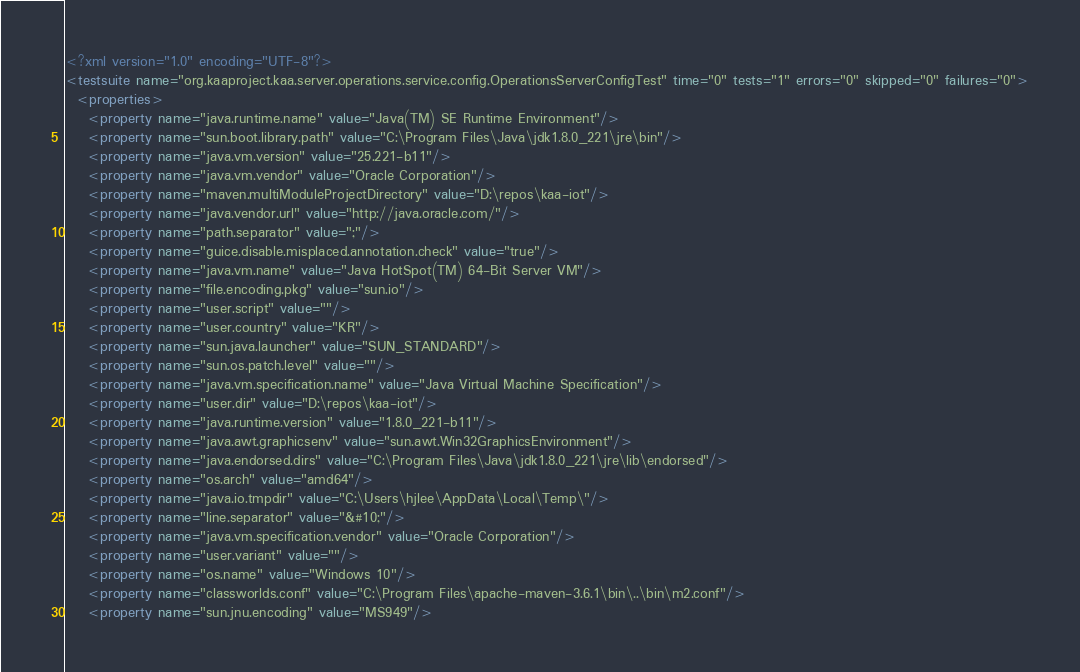<code> <loc_0><loc_0><loc_500><loc_500><_XML_><?xml version="1.0" encoding="UTF-8"?>
<testsuite name="org.kaaproject.kaa.server.operations.service.config.OperationsServerConfigTest" time="0" tests="1" errors="0" skipped="0" failures="0">
  <properties>
    <property name="java.runtime.name" value="Java(TM) SE Runtime Environment"/>
    <property name="sun.boot.library.path" value="C:\Program Files\Java\jdk1.8.0_221\jre\bin"/>
    <property name="java.vm.version" value="25.221-b11"/>
    <property name="java.vm.vendor" value="Oracle Corporation"/>
    <property name="maven.multiModuleProjectDirectory" value="D:\repos\kaa-iot"/>
    <property name="java.vendor.url" value="http://java.oracle.com/"/>
    <property name="path.separator" value=";"/>
    <property name="guice.disable.misplaced.annotation.check" value="true"/>
    <property name="java.vm.name" value="Java HotSpot(TM) 64-Bit Server VM"/>
    <property name="file.encoding.pkg" value="sun.io"/>
    <property name="user.script" value=""/>
    <property name="user.country" value="KR"/>
    <property name="sun.java.launcher" value="SUN_STANDARD"/>
    <property name="sun.os.patch.level" value=""/>
    <property name="java.vm.specification.name" value="Java Virtual Machine Specification"/>
    <property name="user.dir" value="D:\repos\kaa-iot"/>
    <property name="java.runtime.version" value="1.8.0_221-b11"/>
    <property name="java.awt.graphicsenv" value="sun.awt.Win32GraphicsEnvironment"/>
    <property name="java.endorsed.dirs" value="C:\Program Files\Java\jdk1.8.0_221\jre\lib\endorsed"/>
    <property name="os.arch" value="amd64"/>
    <property name="java.io.tmpdir" value="C:\Users\hjlee\AppData\Local\Temp\"/>
    <property name="line.separator" value="&#10;"/>
    <property name="java.vm.specification.vendor" value="Oracle Corporation"/>
    <property name="user.variant" value=""/>
    <property name="os.name" value="Windows 10"/>
    <property name="classworlds.conf" value="C:\Program Files\apache-maven-3.6.1\bin\..\bin\m2.conf"/>
    <property name="sun.jnu.encoding" value="MS949"/></code> 